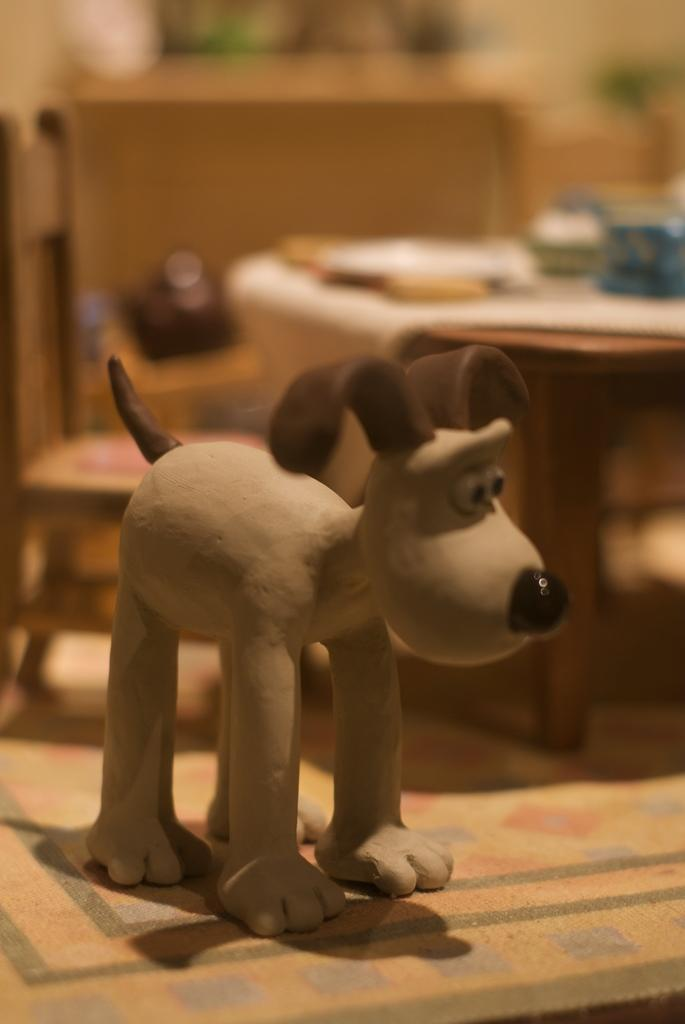What is the main subject of the image? There is a dog made of clay in the image. Where is the clay dog located? The clay dog is on the floor. What furniture can be seen in the background of the image? There is a table and a chair in the background of the image. How would you describe the background of the image? The background is blurred. What type of sound does the ant make while flying in the image? There is no ant or sound present in the image. How many planes can be seen flying in the background of the image? There are no planes visible in the image; it features a clay dog on the floor with a blurred background. 